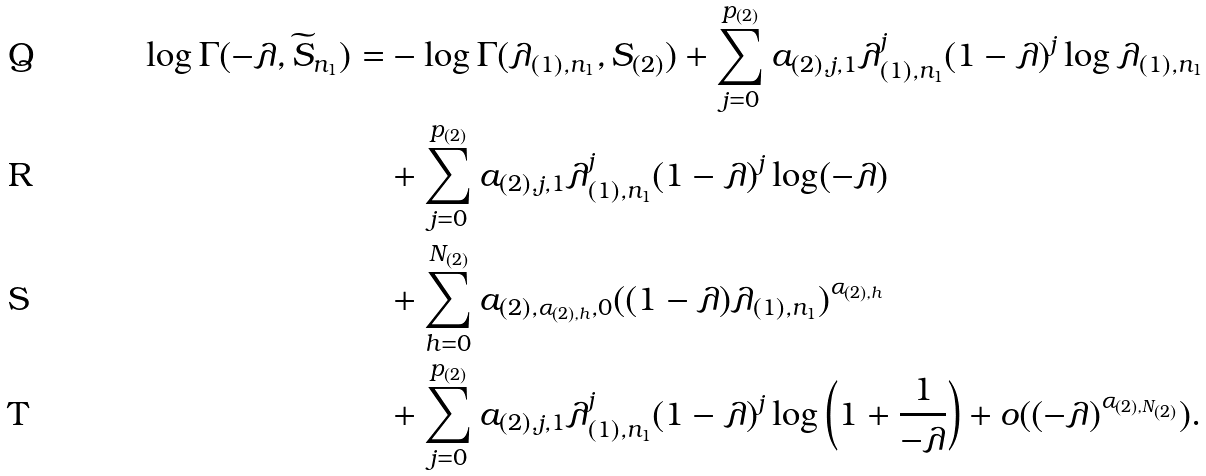<formula> <loc_0><loc_0><loc_500><loc_500>\log \Gamma ( - \lambda , \widetilde { S } _ { n _ { 1 } } ) = & - \log \Gamma ( \lambda _ { ( 1 ) , n _ { 1 } } , S _ { ( 2 ) } ) + \sum _ { j = 0 } ^ { p _ { ( 2 ) } } a _ { ( 2 ) , j , 1 } \lambda _ { ( 1 ) , n _ { 1 } } ^ { j } ( 1 - \lambda ) ^ { j } \log \lambda _ { ( 1 ) , n _ { 1 } } \\ & + \sum _ { j = 0 } ^ { p _ { ( 2 ) } } a _ { ( 2 ) , j , 1 } \lambda _ { ( 1 ) , n _ { 1 } } ^ { j } ( 1 - \lambda ) ^ { j } \log ( - \lambda ) \\ & + \sum _ { h = 0 } ^ { N _ { ( 2 ) } } a _ { ( 2 ) , \alpha _ { ( 2 ) , h } , 0 } ( ( 1 - \lambda ) \lambda _ { ( 1 ) , n _ { 1 } } ) ^ { \alpha _ { ( 2 ) , h } } \\ & + \sum _ { j = 0 } ^ { p _ { ( 2 ) } } a _ { ( 2 ) , j , 1 } \lambda _ { ( 1 ) , n _ { 1 } } ^ { j } ( 1 - \lambda ) ^ { j } \log \left ( 1 + \frac { 1 } { - \lambda } \right ) + o ( ( - \lambda ) ^ { \alpha _ { ( 2 ) , N _ { ( 2 ) } } } ) .</formula> 